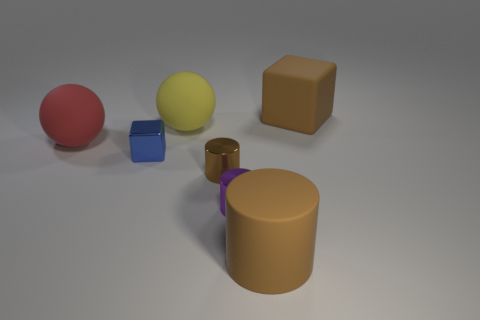Subtract all brown cylinders. How many cylinders are left? 1 Subtract all purple cylinders. How many cylinders are left? 2 Subtract 1 balls. How many balls are left? 1 Subtract all cubes. How many objects are left? 5 Subtract all purple spheres. How many brown cylinders are left? 2 Add 2 tiny blue shiny blocks. How many tiny blue shiny blocks are left? 3 Add 4 big metal cylinders. How many big metal cylinders exist? 4 Add 2 tiny things. How many objects exist? 9 Subtract 0 gray balls. How many objects are left? 7 Subtract all brown cubes. Subtract all brown cylinders. How many cubes are left? 1 